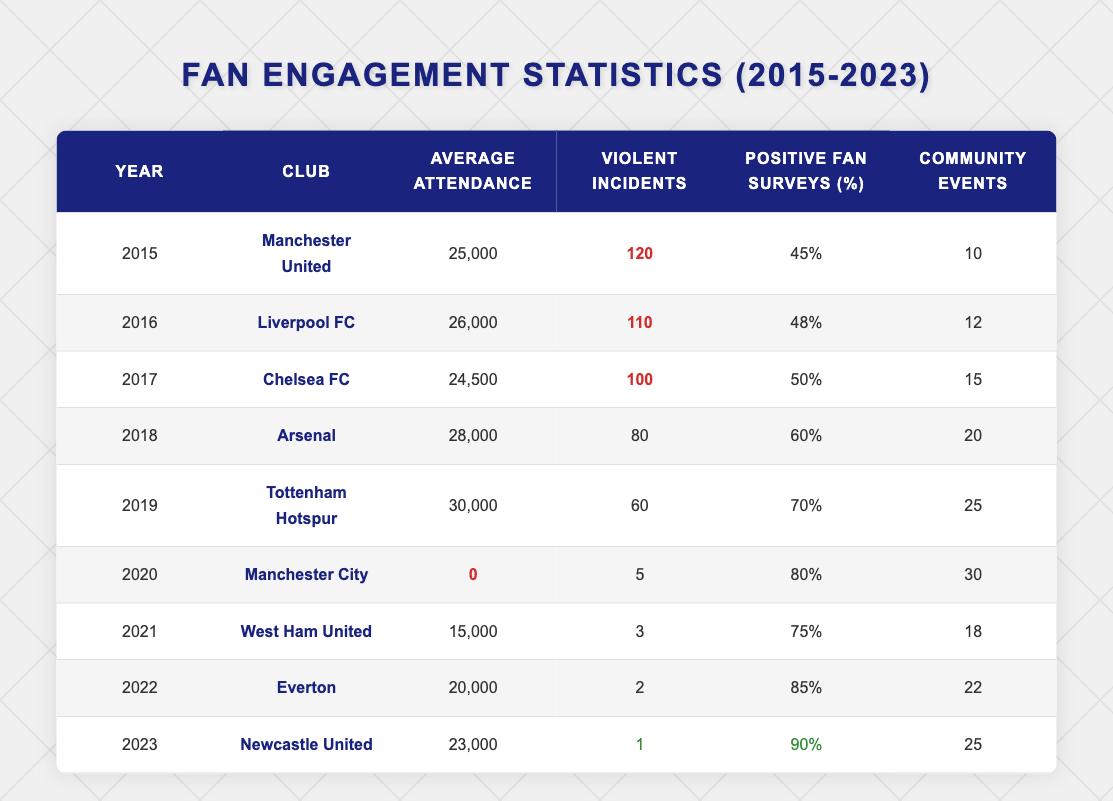What was the average attendance in 2019? The table shows the average attendance for each year. In 2019, it indicates an average attendance of 30,000.
Answer: 30,000 How many violent incidents were recorded in 2021? By checking the 2021 row of the table, the number of violent incidents is listed as 3.
Answer: 3 Which club had the highest positive fan survey percentage in 2023? Looking at the 2023 data, Newcastle United has a positive fan survey percentage of 90%, which is higher than any other club.
Answer: Newcastle United What is the difference in the average attendance between 2015 and 2018? In 2015, the average attendance was 25,000, and in 2018, it was 28,000. The difference is 28,000 - 25,000 = 3,000.
Answer: 3,000 Did the number of violent incidents decrease from 2015 to 2023? In 2015 there were 120 violent incidents and in 2023 there was only 1. Since 1 is less than 120, it confirms a decrease.
Answer: Yes How many more community events were held in 2022 compared to 2016? In 2022, there were 22 community events, and in 2016, there were 12. The difference is 22 - 12 = 10.
Answer: 10 What was the average percentage of positive fan surveys from 2015 to 2019? The percentages from 2015 to 2019 are: 45%, 48%, 50%, 60%, and 70%. Adding them gives 45 + 48 + 50 + 60 + 70 = 273. There are 5 years, so the average is 273 / 5 = 54.6%.
Answer: 54.6% Which year had the least number of violent incidents? Looking through all the years, the least number of violent incidents recorded was 1 in 2023.
Answer: 2023 How many community events did Manchester City hold in 2020? The data for 2020 shows that Manchester City held 30 community events.
Answer: 30 In which year was the highest average attendance recorded, and what was that attendance? The highest average attendance is 30,000, which occurred in 2019.
Answer: 2019, 30,000 How many total violent incidents were recorded from 2015 to 2022? Adding up the violent incidents for the specified years: 120 + 110 + 100 + 80 + 60 + 5 + 3 + 2 = 480.
Answer: 480 Was the average attendance higher in 2022 than in 2020? The average attendance in 2022 was 20,000 while in 2020 it was 0. Since 20,000 is greater, the statement is true.
Answer: Yes How did the number of positive fan survey results change from 2016 to 2022? In 2016, the positive fan surveys were at 48% and in 2022 it rose to 85%, indicating an increase of 37%.
Answer: Increased by 37% 